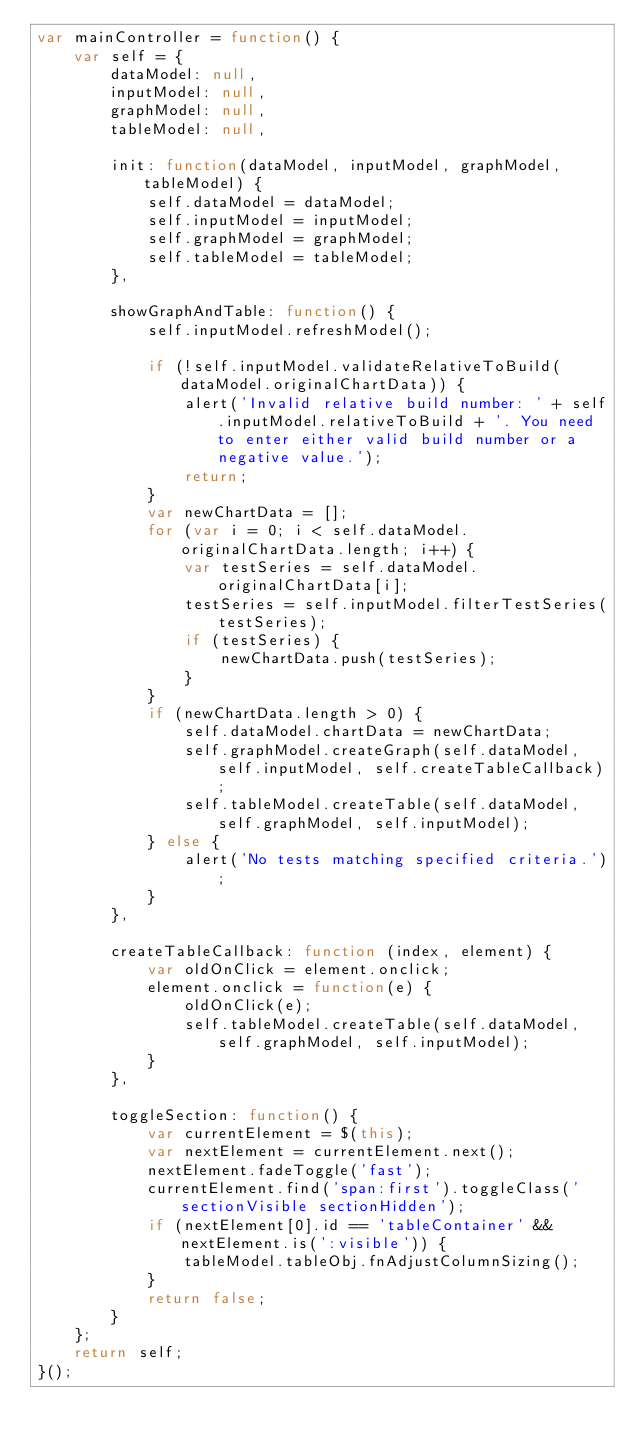Convert code to text. <code><loc_0><loc_0><loc_500><loc_500><_JavaScript_>var mainController = function() {
    var self = {
        dataModel: null,
        inputModel: null,
        graphModel: null,
        tableModel: null,

        init: function(dataModel, inputModel, graphModel, tableModel) {
            self.dataModel = dataModel;
            self.inputModel = inputModel;
            self.graphModel = graphModel;
            self.tableModel = tableModel;
        },

        showGraphAndTable: function() {
            self.inputModel.refreshModel();

            if (!self.inputModel.validateRelativeToBuild(dataModel.originalChartData)) {
                alert('Invalid relative build number: ' + self.inputModel.relativeToBuild + '. You need to enter either valid build number or a negative value.');
                return;
            }
            var newChartData = [];
            for (var i = 0; i < self.dataModel.originalChartData.length; i++) {
                var testSeries = self.dataModel.originalChartData[i];
                testSeries = self.inputModel.filterTestSeries(testSeries);
                if (testSeries) { 
                    newChartData.push(testSeries);
                }
            }
            if (newChartData.length > 0) {
                self.dataModel.chartData = newChartData;
                self.graphModel.createGraph(self.dataModel, self.inputModel, self.createTableCallback);
                self.tableModel.createTable(self.dataModel, self.graphModel, self.inputModel);
            } else {
                alert('No tests matching specified criteria.');
            }
        },

        createTableCallback: function (index, element) {
            var oldOnClick = element.onclick;
            element.onclick = function(e) {
                oldOnClick(e);
                self.tableModel.createTable(self.dataModel, self.graphModel, self.inputModel);
            }
        },

        toggleSection: function() {
            var currentElement = $(this);
            var nextElement = currentElement.next();
            nextElement.fadeToggle('fast');
            currentElement.find('span:first').toggleClass('sectionVisible sectionHidden');    
            if (nextElement[0].id == 'tableContainer' && nextElement.is(':visible')) {  
                tableModel.tableObj.fnAdjustColumnSizing();  
            }
            return false;
        }
    };
    return self;
}();</code> 